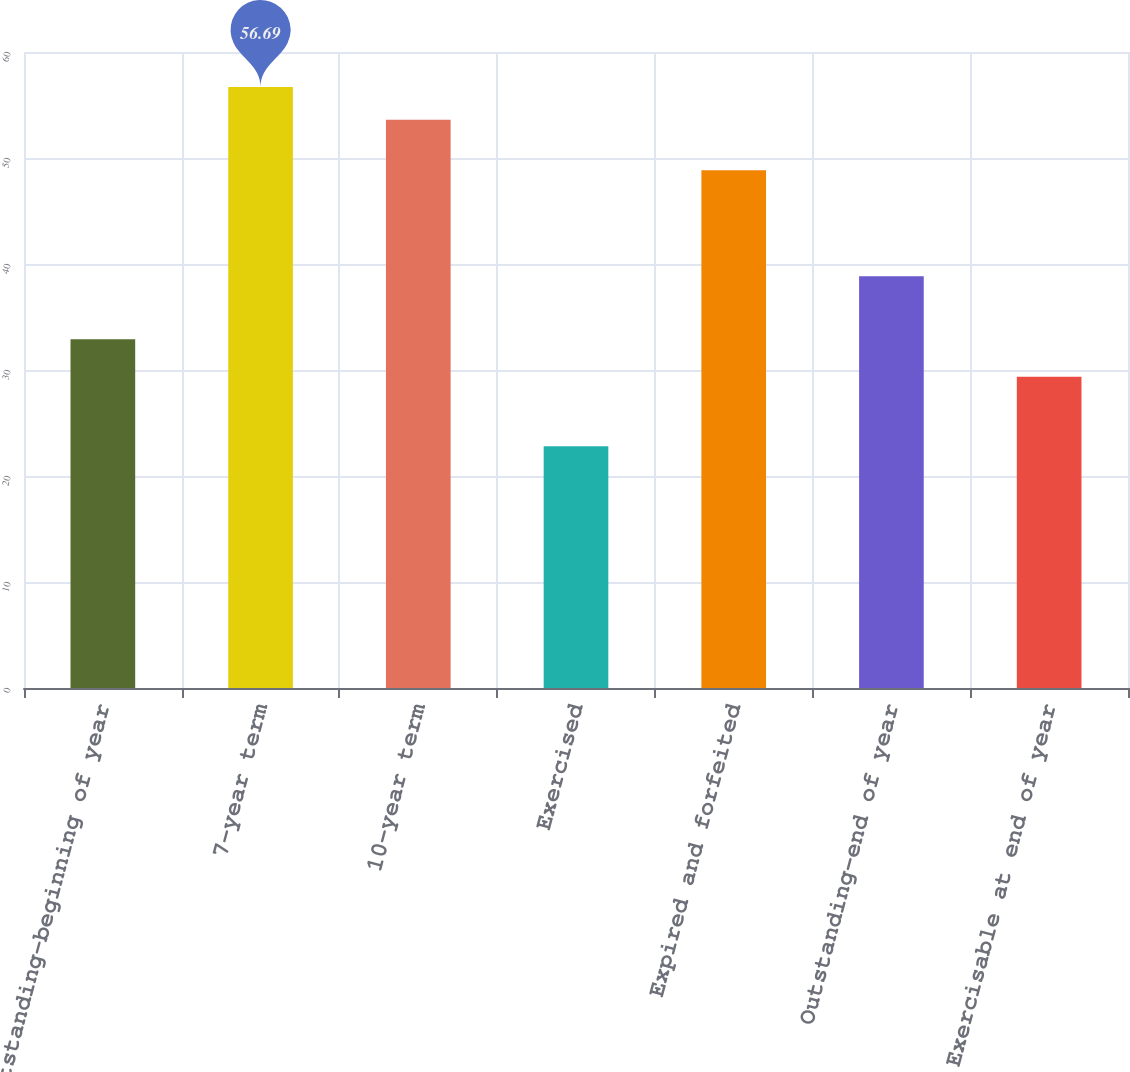Convert chart to OTSL. <chart><loc_0><loc_0><loc_500><loc_500><bar_chart><fcel>Outstanding-beginning of year<fcel>7-year term<fcel>10-year term<fcel>Exercised<fcel>Expired and forfeited<fcel>Outstanding-end of year<fcel>Exercisable at end of year<nl><fcel>32.91<fcel>56.69<fcel>53.61<fcel>22.81<fcel>48.85<fcel>38.84<fcel>29.37<nl></chart> 